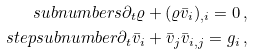Convert formula to latex. <formula><loc_0><loc_0><loc_500><loc_500>\ s u b n u m b e r s \partial _ { t } \varrho + ( \varrho { \bar { v } } _ { i } ) _ { , i } = 0 \, , \\ \ s t e p s u b n u m b e r \partial _ { t } { \bar { v } } _ { i } + { \bar { v } } _ { j } { \bar { v } } _ { i , j } = g _ { i } \, ,</formula> 